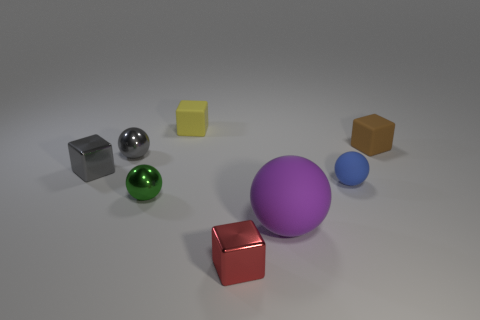There is a rubber thing in front of the green thing; is its shape the same as the small red object?
Provide a succinct answer. No. Is there any other thing that has the same shape as the purple thing?
Offer a terse response. Yes. How many blocks are either tiny red things or small blue things?
Provide a succinct answer. 1. How many matte objects are there?
Your response must be concise. 4. There is a block behind the cube right of the big purple sphere; what is its size?
Provide a succinct answer. Small. How many other things are the same size as the blue object?
Ensure brevity in your answer.  6. There is a blue ball; how many blocks are behind it?
Your response must be concise. 3. How big is the purple object?
Make the answer very short. Large. Are the cube right of the small red shiny block and the small red cube left of the big thing made of the same material?
Provide a short and direct response. No. Is there a shiny cube that has the same color as the large matte sphere?
Make the answer very short. No. 